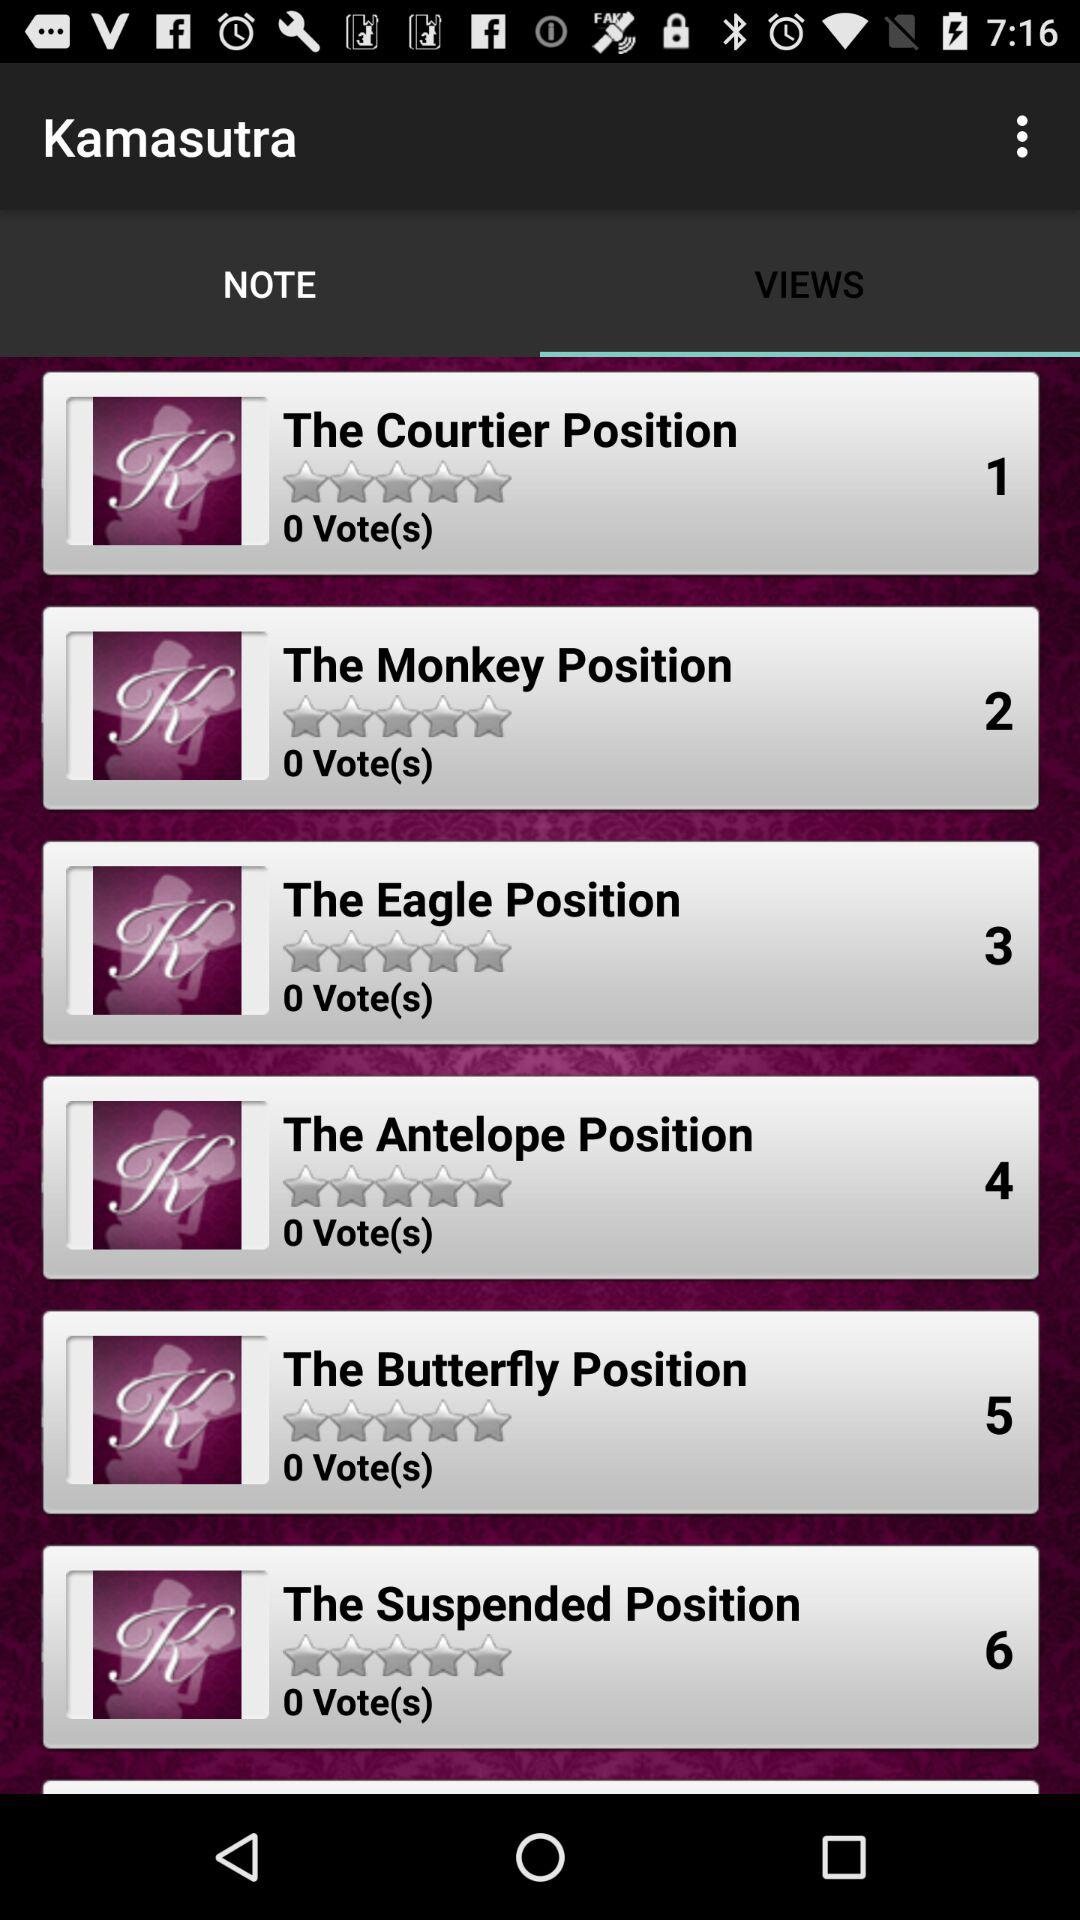What is the serial number of the suspended position? The serial number is 6. 